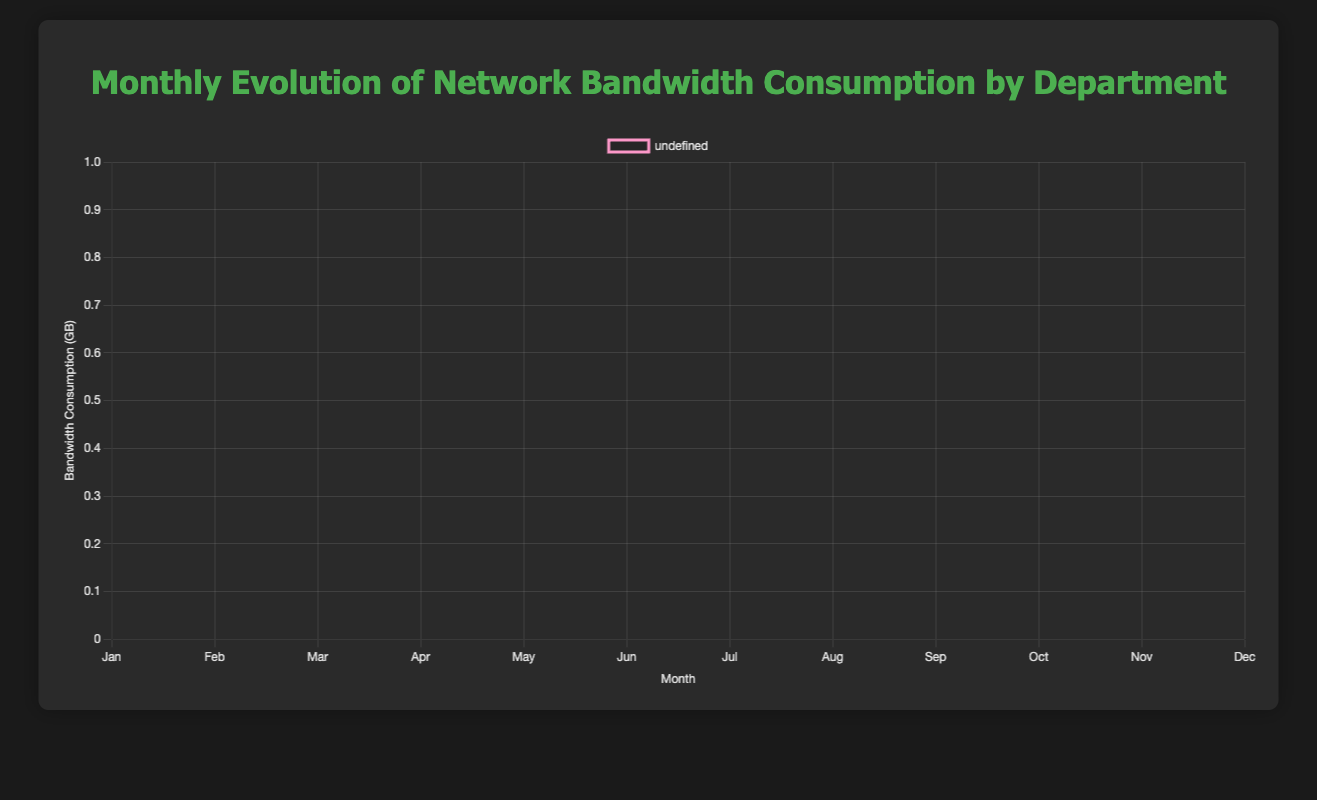What's the trend in bandwidth consumption for the IT department? The bandwidth consumption in the IT department starts high in January with 750 GB, sees slight increases and decreases, with peaks in February and August at 770 GB and September at 780 GB, before dropping back to 730 GB in December.
Answer: Fluctuating, peaking in Feb, Aug, and Sep Which department has the highest bandwidth consumption overall? By visually examining the heights of the curves, it's clear that the IT department consistently has the highest bandwidth consumption each month, never dipping below 730 GB.
Answer: IT Compare the average bandwidth consumption between the HR and Engineering departments. Calculate the total bandwidth consumption for HR (120+110+140+130+115+125+135+145+130+120+110+125=1505 GB) and for Engineering (500+520+530+540+550+560+570+580+560+550+540+530=6530 GB). Divide each by 12 months. HR: 1505/12 = 125.42 GB, Engineering: 6530/12 = 544.17 GB.
Answer: HR: 125.42 GB, Engineering: 544.17 GB In which month did the Finance department consume the most bandwidth? By comparing the data points for the Finance department, the highest bandwidth consumption occurs in July with 360 GB.
Answer: July Calculate the difference in bandwidth consumption between the Marketing and Finance departments in March. In March, Marketing consumed 260 GB while Finance consumed 340 GB. The difference is 340 - 260 = 80 GB.
Answer: 80 GB Which department showed the largest increase in bandwidth consumption from January to December? For each department, calculate the difference between January and December values: HR (125-120=5), Finance (330-300=30), Engineering (530-500=30), Marketing (270-250=20), IT (730-750=-20). Finance and Engineering show the largest increase of 30 GB.
Answer: Finance and Engineering How does the bandwidth consumption for the IT department in June compare to that in September? In June, the IT department consumed 730 GB, and in September, it consumed 780 GB. September's consumption is higher by 50 GB.
Answer: September is higher by 50 GB What is the general trend for the Finance department's bandwidth consumption over the months? The trend shows minor fluctuations, starting at 300 GB in January, peaking at 360 GB in July, and returning to 330 GB in December. Small peaks and declines are observed throughout the year.
Answer: Minor fluctuations, peak in July Compare the bandwidth consumption of HR and Marketing in April. HR consumed 130 GB in April, while Marketing consumed 270 GB, thus Marketing consumed more.
Answer: Marketing consumed more Which month shows the highest bandwidth consumption for Engineering? By visually comparing all months for Engineering, August has the highest consumption at 580 GB.
Answer: August 